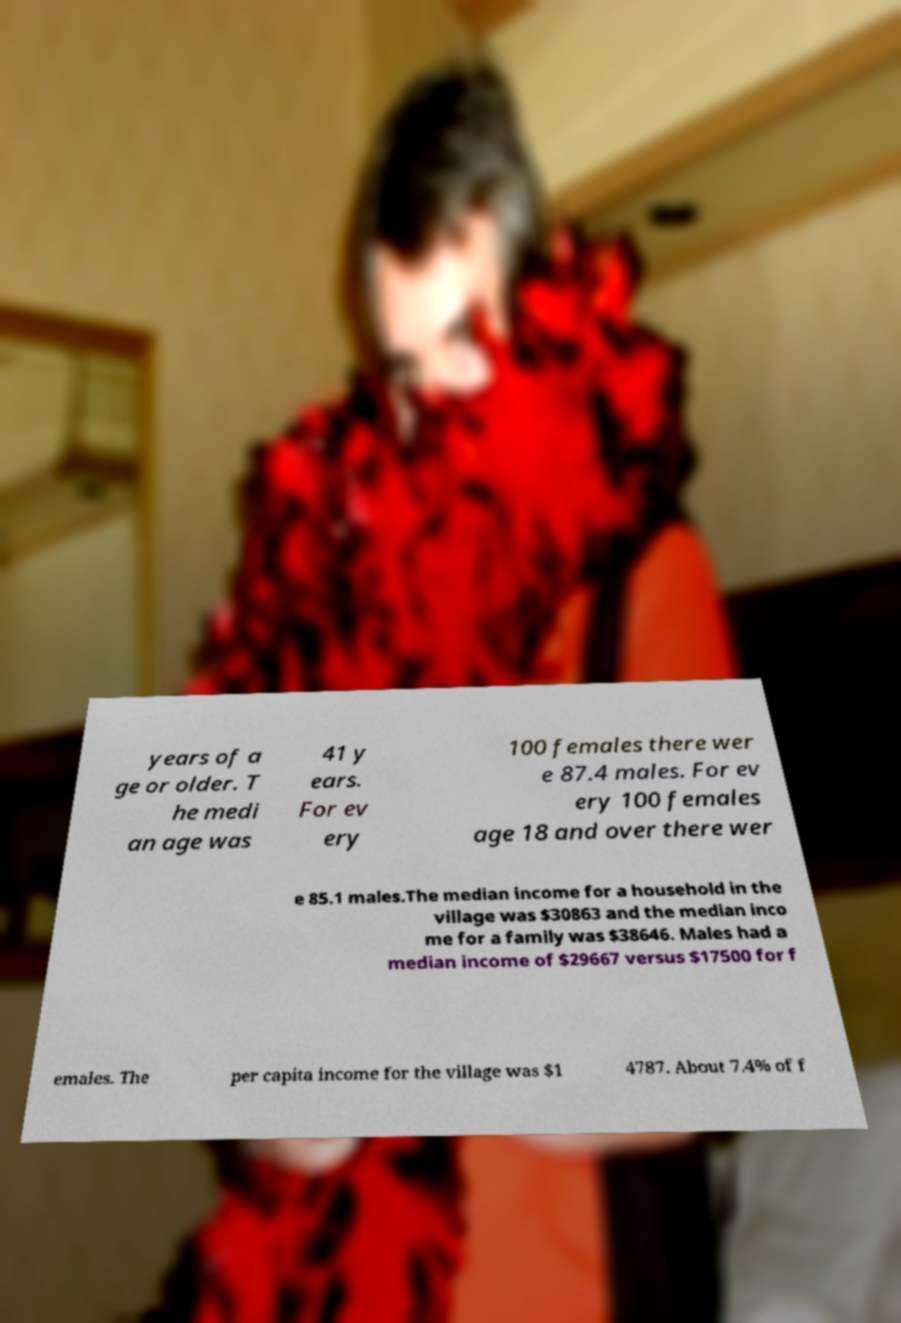What messages or text are displayed in this image? I need them in a readable, typed format. years of a ge or older. T he medi an age was 41 y ears. For ev ery 100 females there wer e 87.4 males. For ev ery 100 females age 18 and over there wer e 85.1 males.The median income for a household in the village was $30863 and the median inco me for a family was $38646. Males had a median income of $29667 versus $17500 for f emales. The per capita income for the village was $1 4787. About 7.4% of f 